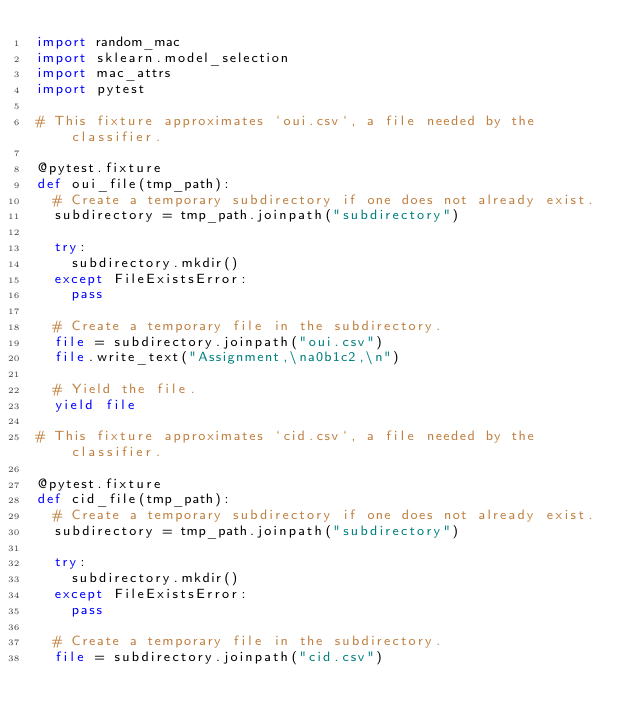Convert code to text. <code><loc_0><loc_0><loc_500><loc_500><_Python_>import random_mac
import sklearn.model_selection
import mac_attrs
import pytest

# This fixture approximates `oui.csv`, a file needed by the classifier.

@pytest.fixture
def oui_file(tmp_path):
  # Create a temporary subdirectory if one does not already exist.
  subdirectory = tmp_path.joinpath("subdirectory")

  try:
    subdirectory.mkdir()
  except FileExistsError:
    pass

  # Create a temporary file in the subdirectory.
  file = subdirectory.joinpath("oui.csv")
  file.write_text("Assignment,\na0b1c2,\n")

  # Yield the file.
  yield file

# This fixture approximates `cid.csv`, a file needed by the classifier.

@pytest.fixture
def cid_file(tmp_path):
  # Create a temporary subdirectory if one does not already exist.
  subdirectory = tmp_path.joinpath("subdirectory")

  try:
    subdirectory.mkdir()
  except FileExistsError:
    pass

  # Create a temporary file in the subdirectory.
  file = subdirectory.joinpath("cid.csv")</code> 